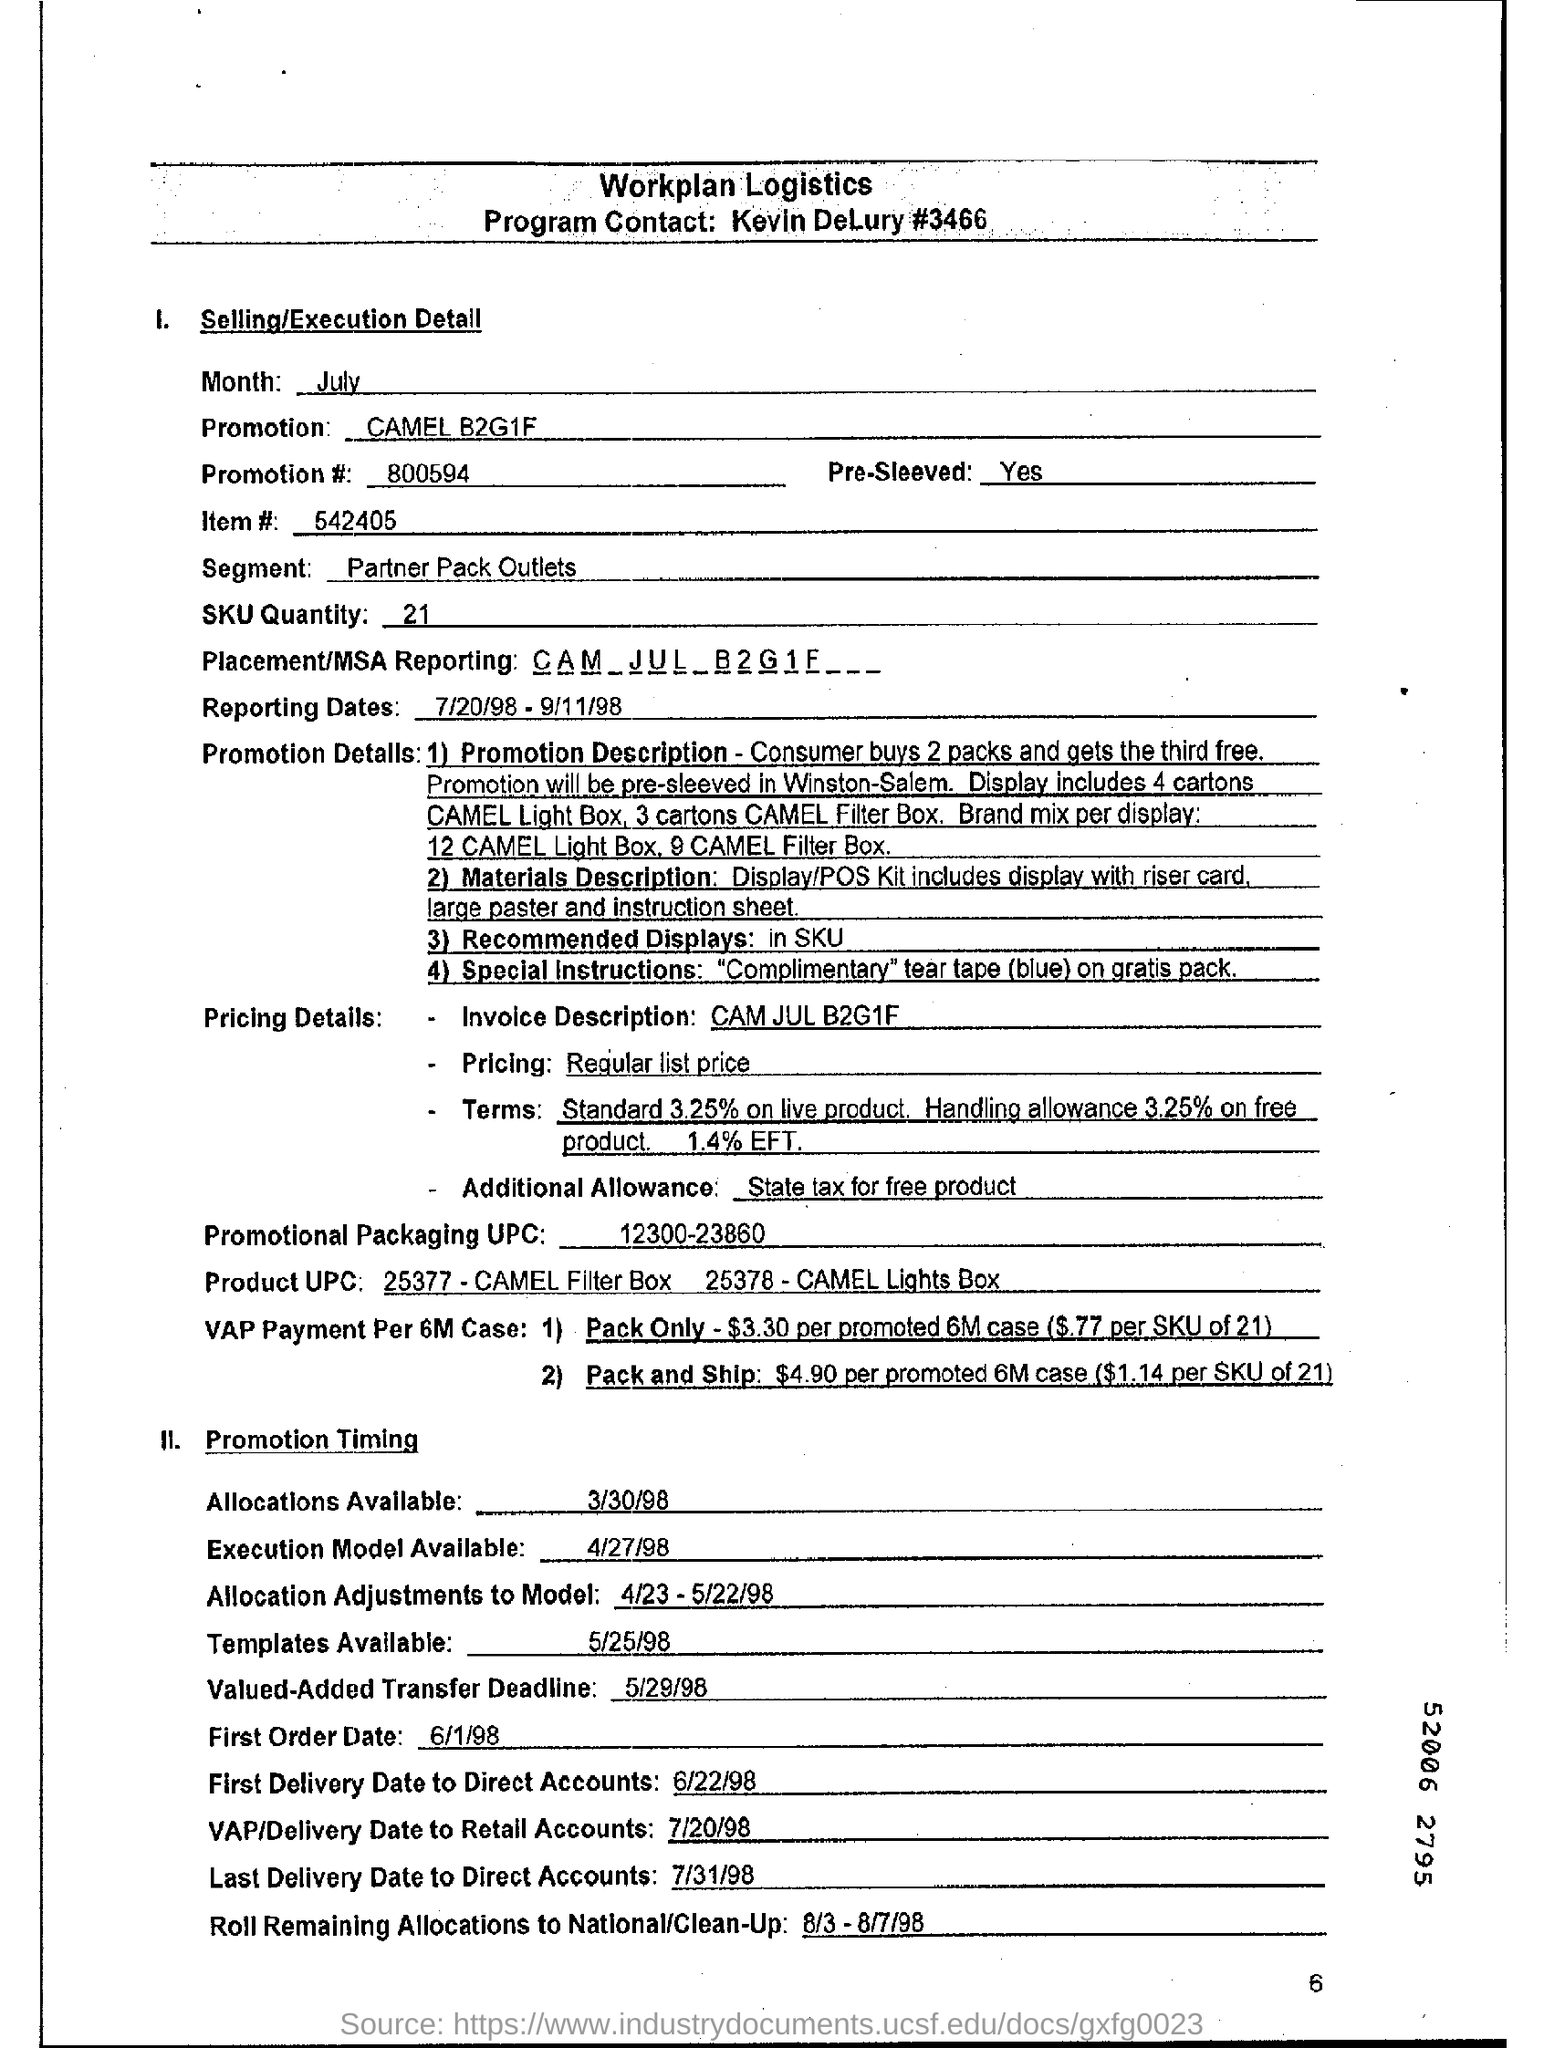Which brand's promotion is given here?
Your answer should be very brief. CAMEL B2G1F. What is the Promotion #  mentioned in the document?
Provide a succinct answer. 800594. What is the SKU Quantity given?
Make the answer very short. 21. What is the Promotional Packaging UPC  mentioned in the document?
Provide a short and direct response. 12300-23860. What is the reporting dates as per the dcoument?
Make the answer very short. 7/20/98 - 9/11/98. Who is the Program Contact?
Provide a succinct answer. Kevin DeLury #3466. 